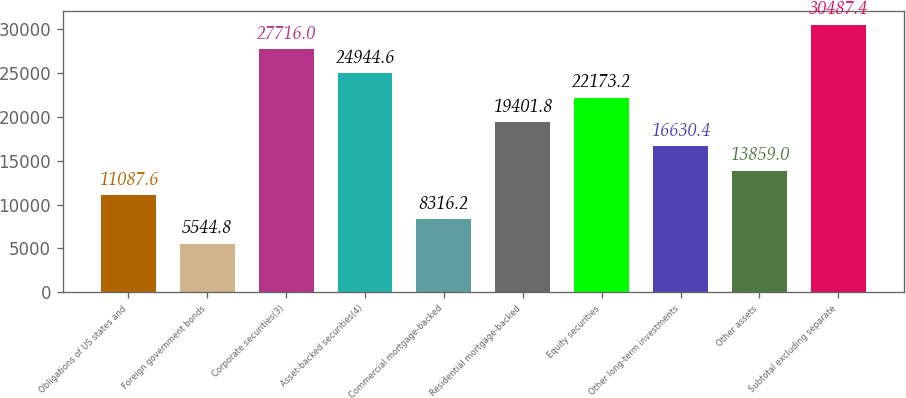Convert chart to OTSL. <chart><loc_0><loc_0><loc_500><loc_500><bar_chart><fcel>Obligations of US states and<fcel>Foreign government bonds<fcel>Corporate securities(3)<fcel>Asset-backed securities(4)<fcel>Commercial mortgage-backed<fcel>Residential mortgage-backed<fcel>Equity securities<fcel>Other long-term investments<fcel>Other assets<fcel>Subtotal excluding separate<nl><fcel>11087.6<fcel>5544.8<fcel>27716<fcel>24944.6<fcel>8316.2<fcel>19401.8<fcel>22173.2<fcel>16630.4<fcel>13859<fcel>30487.4<nl></chart> 